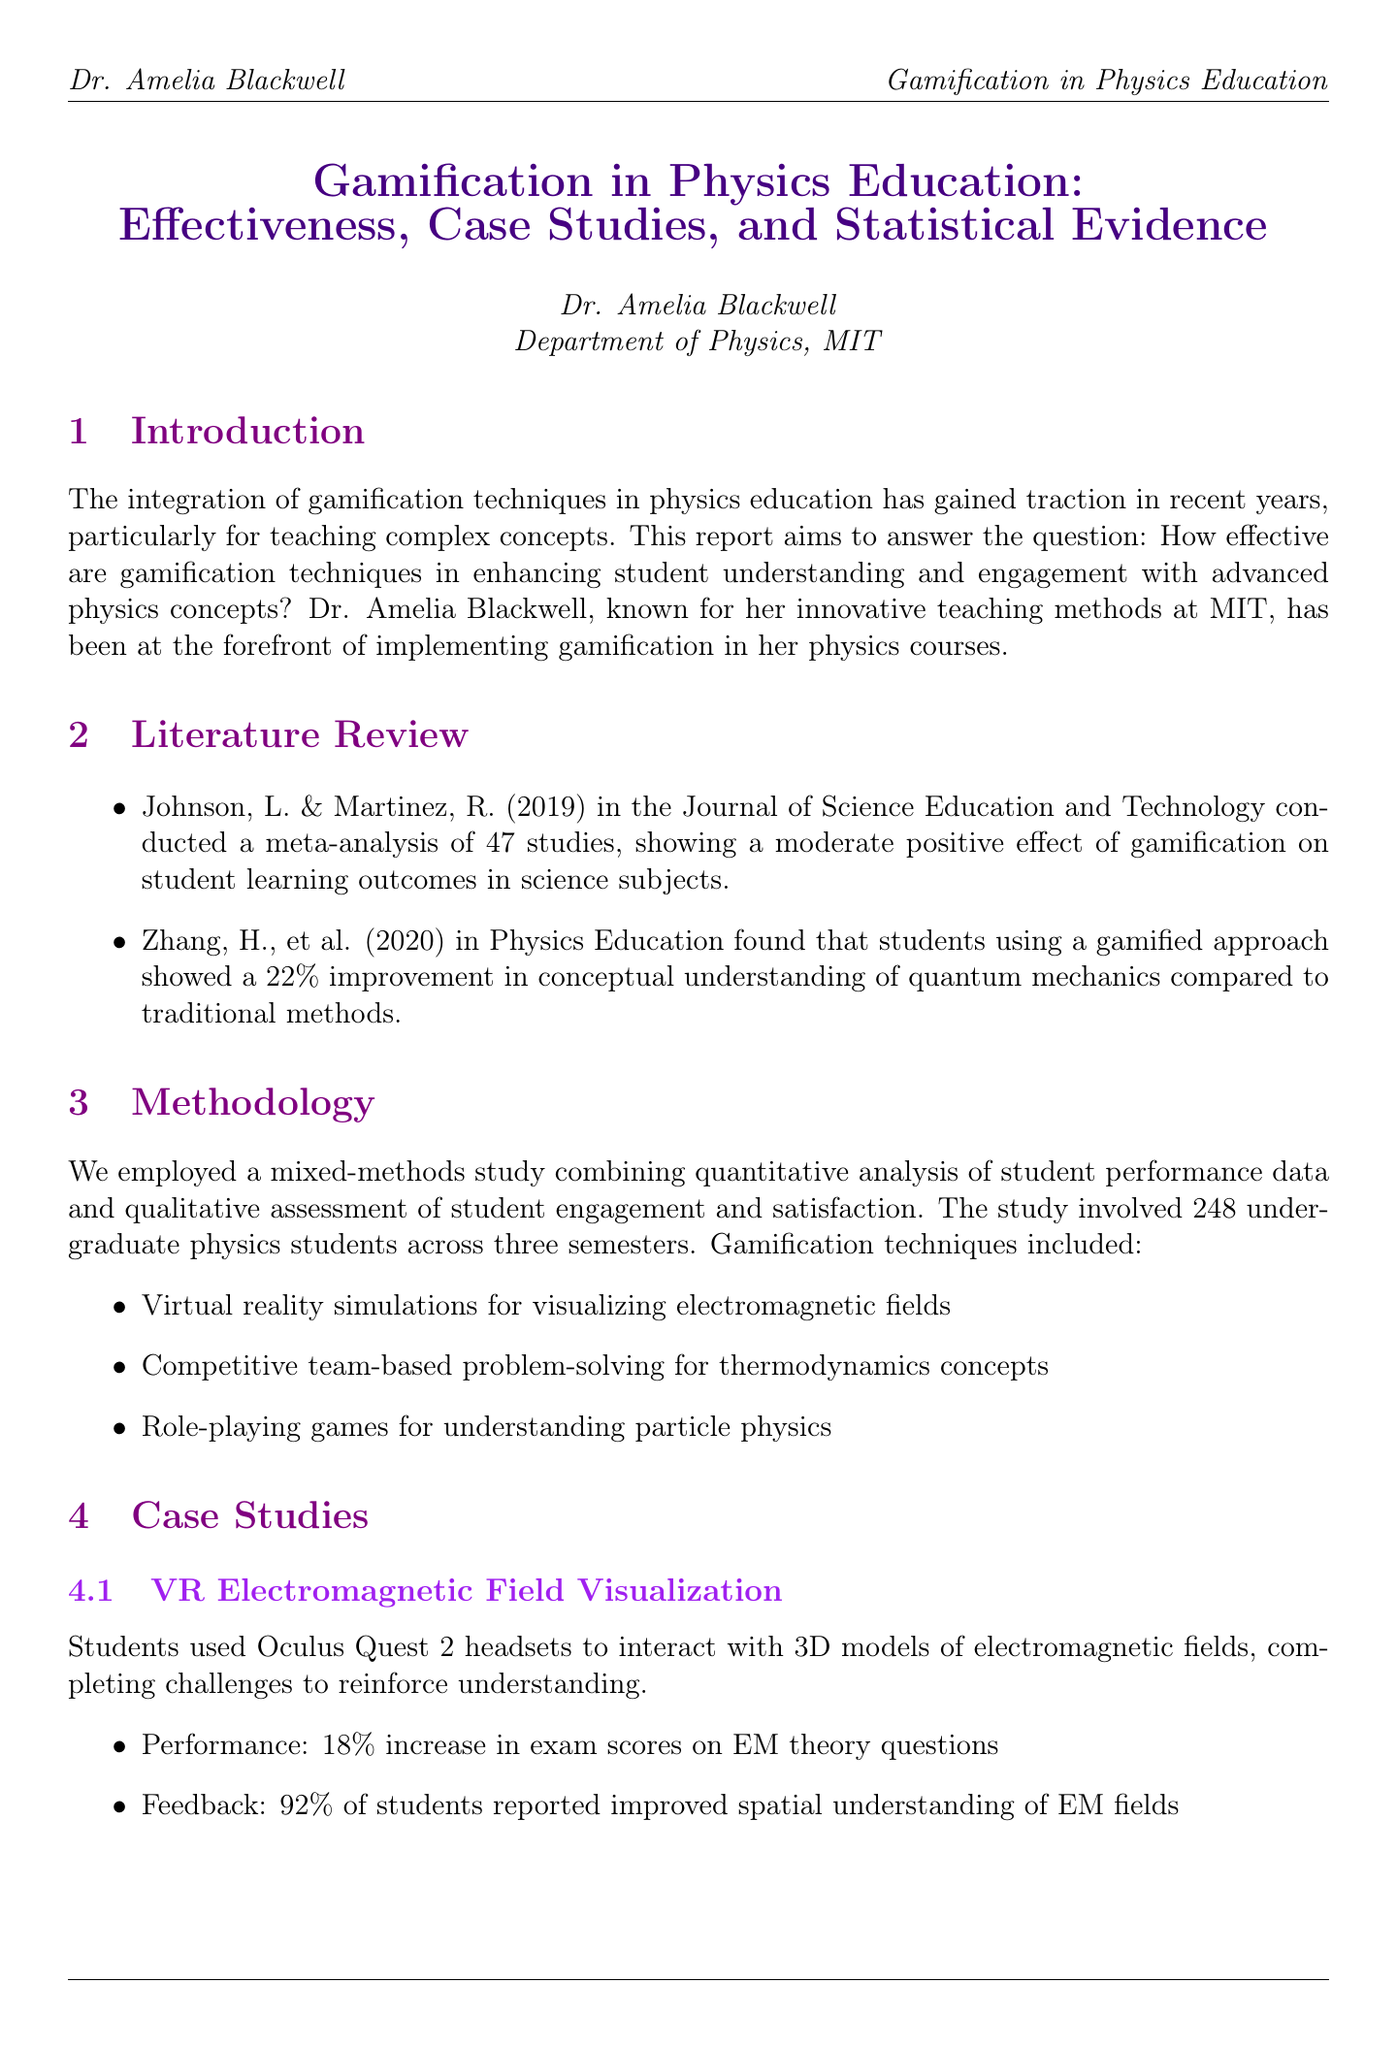What is the report title? The title is provided at the beginning of the document, summarizing the focus of the report.
Answer: Gamification in Physics Education: Effectiveness, Case Studies, and Statistical Evidence Who conducted the systematic review on gamification in science education? The literature review cites specific authors who conducted relevant studies, including their findings.
Answer: Johnson, L. & Martinez, R What percentage of improvement did students achieve in the particle physics midterm? The case study on particle physics provides the performance improvement as a result of gamified techniques.
Answer: 25% What was the average grade increase for students in gamified semesters? The statistical evidence section details the performance metrics comparing gamified and non-gamified semesters.
Answer: 16.7% How many undergraduate physics students participated in the study? The methodology overview states the number of participants involved in the study directly.
Answer: 248 What year was the study on game-based learning and quantum mechanics published? The literature review specifies the year of publication for the cited study on quantum mechanics.
Answer: 2020 What technology was used for visualizing electromagnetic fields? The methodology mentions the specific technology employed as part of the gamification techniques.
Answer: Oculus Quest 2 What is one recommendation made in the conclusions? The conclusions section outlines suggestions for educators on implementing gamification in physics education.
Answer: Gradual integration of gamified elements into existing curricula 